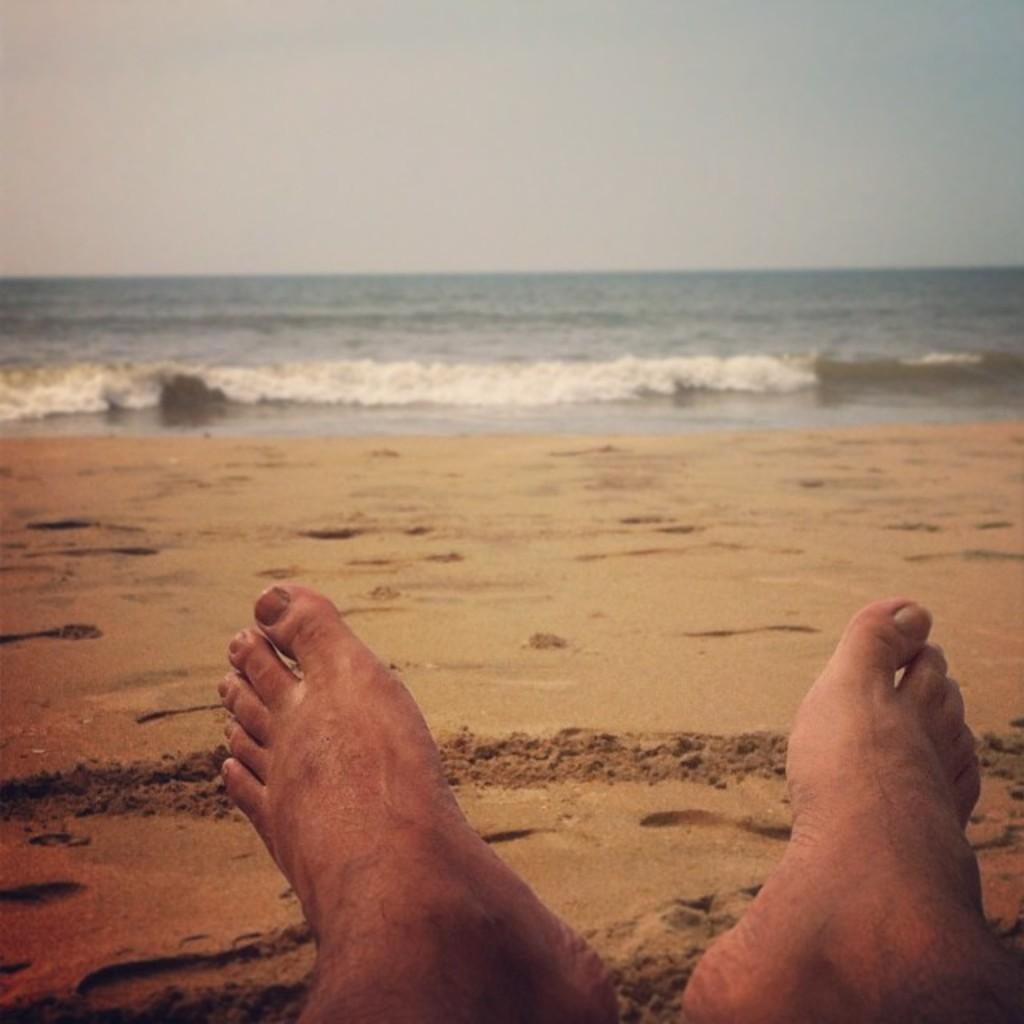What type of location is depicted in the image? The image contains a beach view. What is a characteristic feature of the beach? There is sand visible in the beach in the image. Can you describe the position of the persons in the image? There are persons' toes on the sand. What can be seen in the distance from the beach? There is water visible in the background of the image, and the water has tides. What else is visible in the background of the image? The sky is visible in the background of the image. What type of boat is visible in the image? There is no boat present in the image; it features a beach view with sand, persons' toes, water, and a sky. Can you describe the house located near the beach in the image? There is no house mentioned or visible in the image; it only shows a beach view with sand, persons' toes, water, and a sky. 